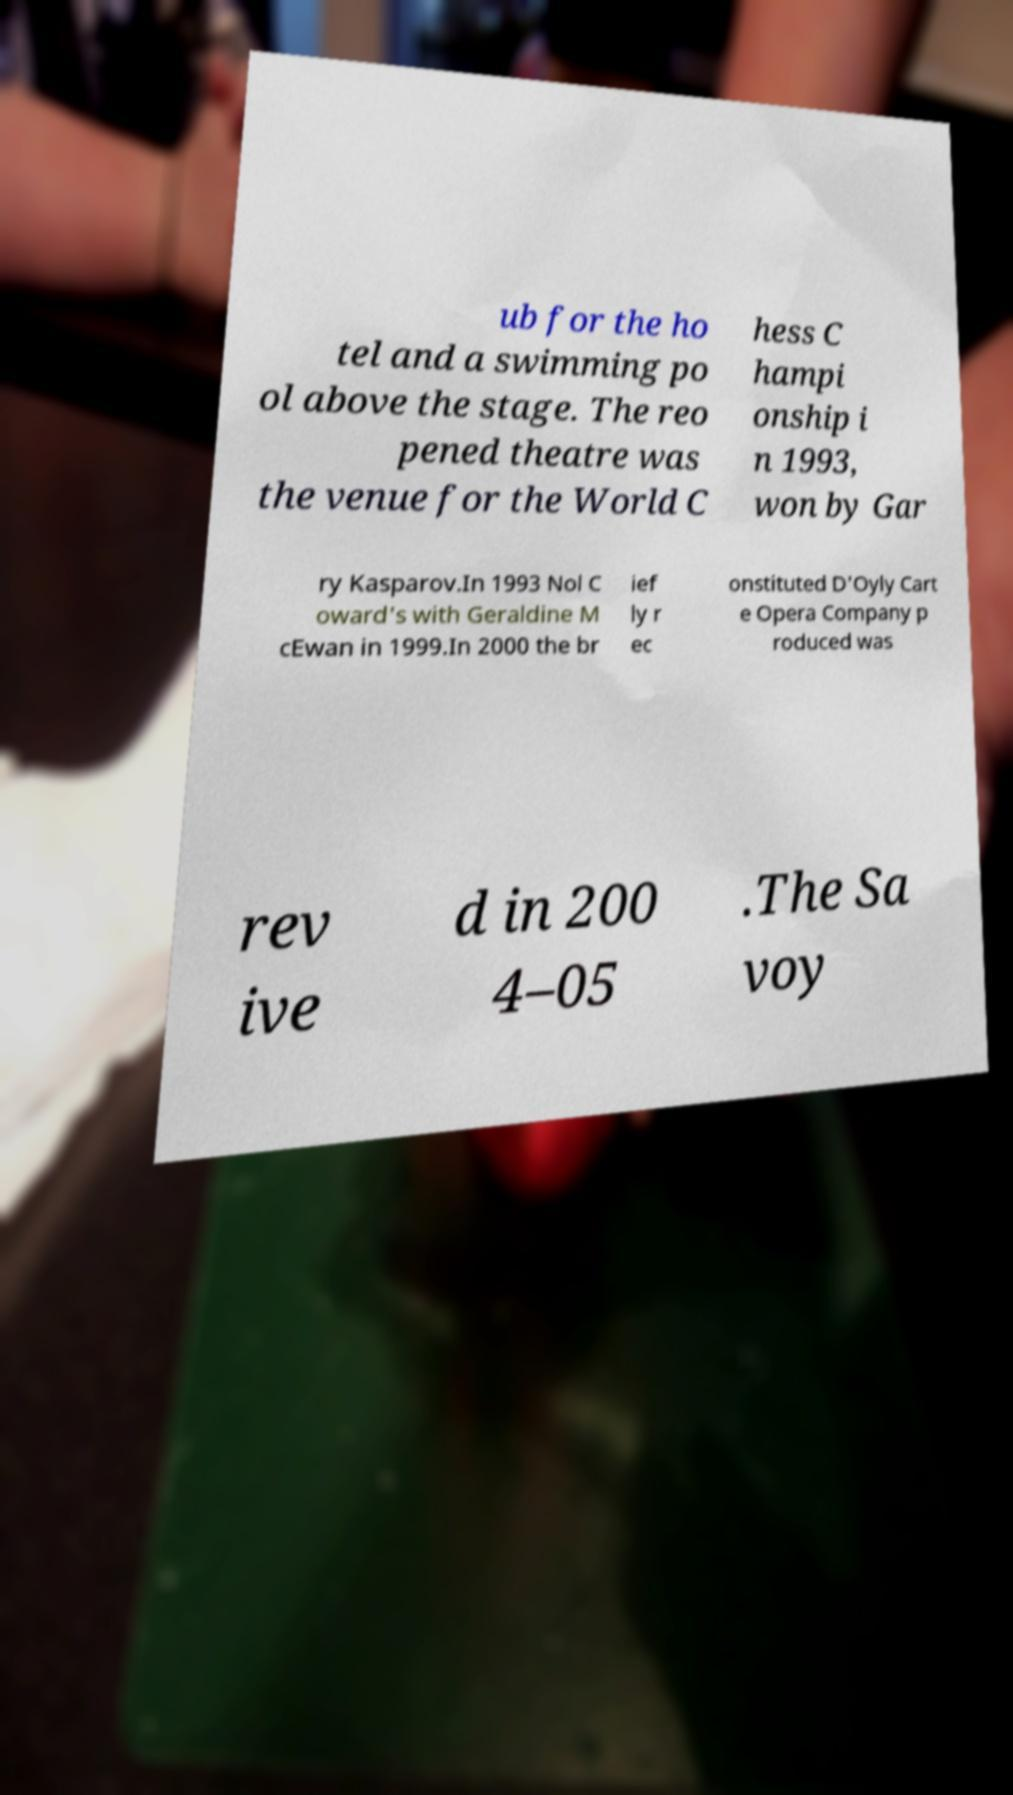Can you read and provide the text displayed in the image?This photo seems to have some interesting text. Can you extract and type it out for me? ub for the ho tel and a swimming po ol above the stage. The reo pened theatre was the venue for the World C hess C hampi onship i n 1993, won by Gar ry Kasparov.In 1993 Nol C oward's with Geraldine M cEwan in 1999.In 2000 the br ief ly r ec onstituted D'Oyly Cart e Opera Company p roduced was rev ive d in 200 4–05 .The Sa voy 